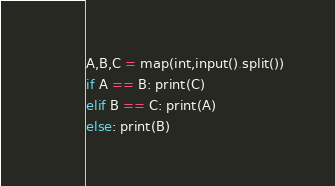Convert code to text. <code><loc_0><loc_0><loc_500><loc_500><_Python_>A,B,C = map(int,input().split())
if A == B: print(C)
elif B == C: print(A)
else: print(B)</code> 